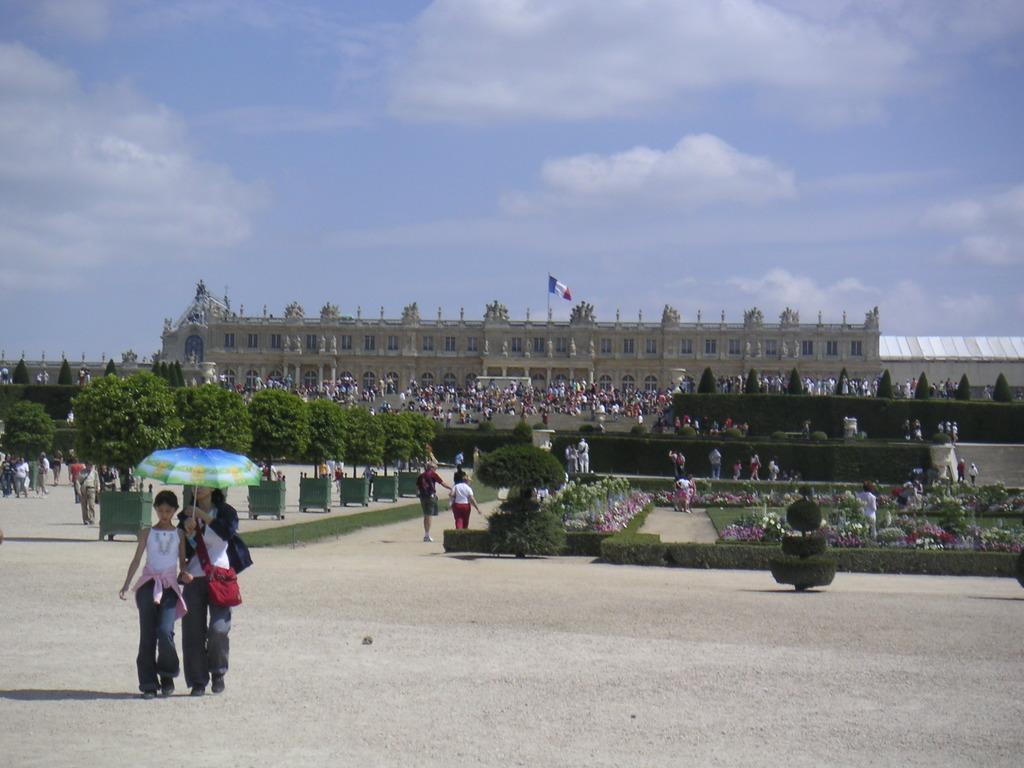In one or two sentences, can you explain what this image depicts? In this image in the center there are persons walking and there is a man holding an umbrella which is blue in colour. In the background there are plants, there is a building and on the top of the building there is a flag and there are persons and the sky is cloudy. 